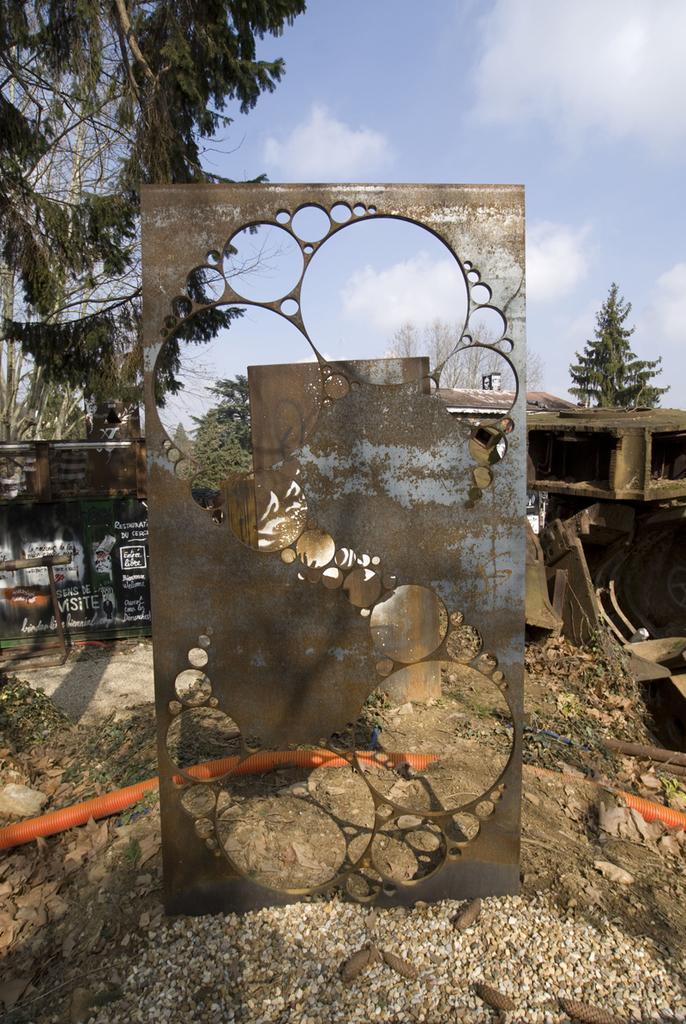Please provide a concise description of this image. In this image there is a steel frame, behind it there are few objects, a frame with some text, few trees, grass and some clouds in the sky. 